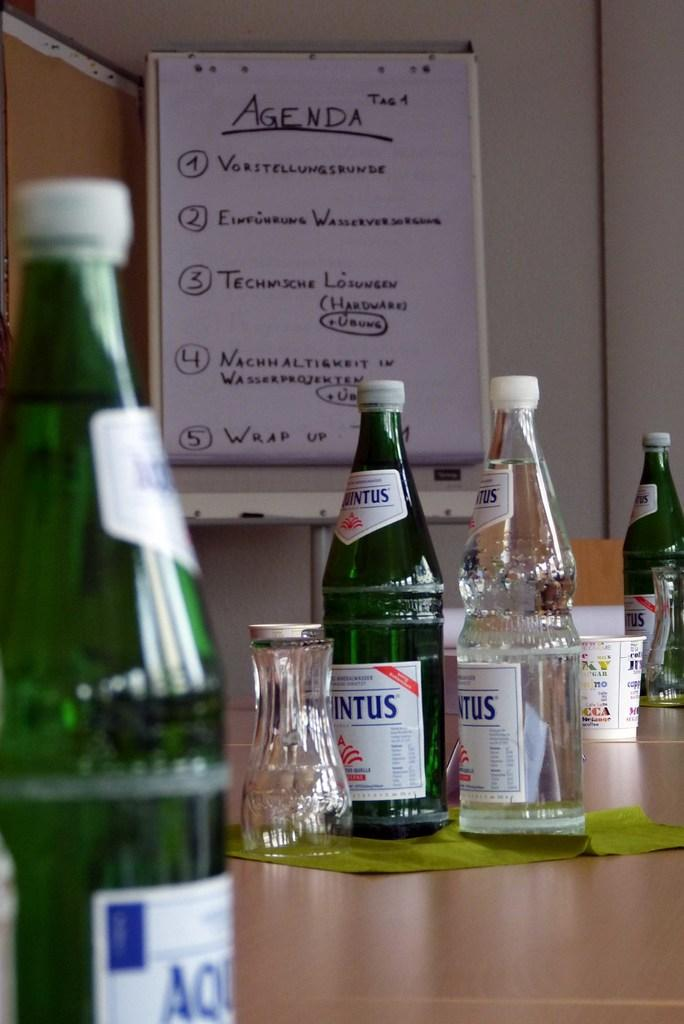<image>
Provide a brief description of the given image. on the wall of a diner is a sign with the agenda of the day 